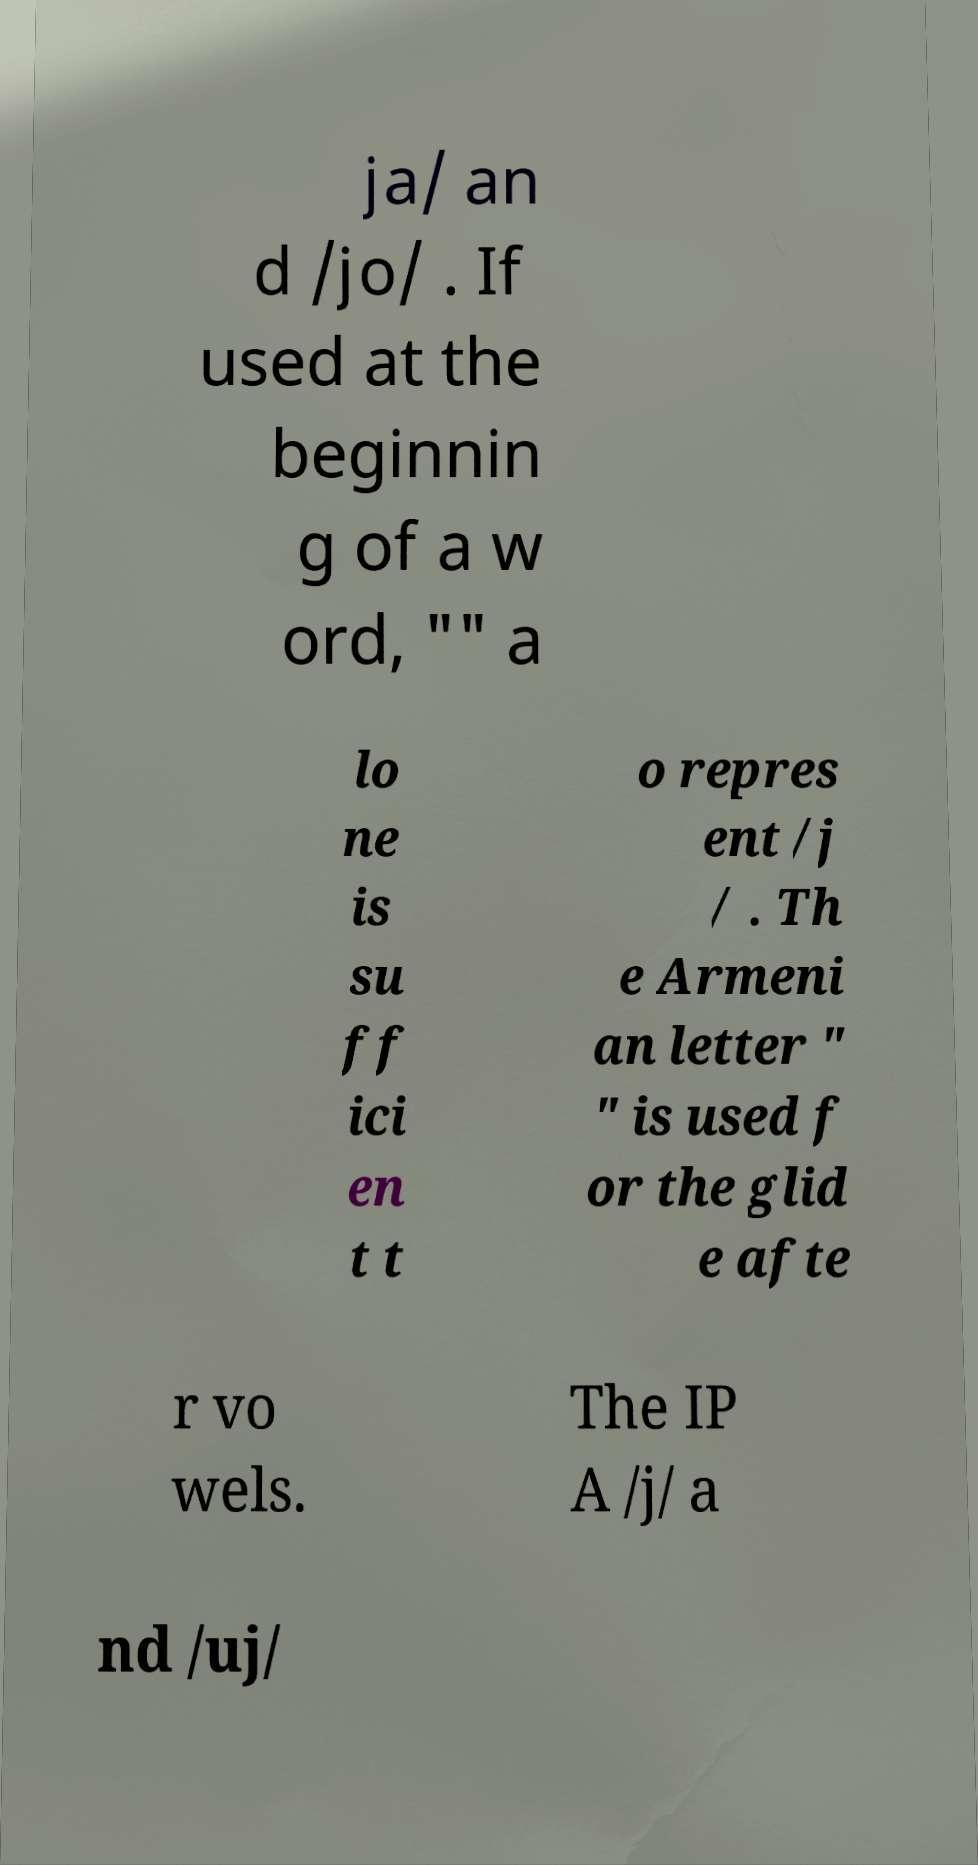There's text embedded in this image that I need extracted. Can you transcribe it verbatim? ja/ an d /jo/ . If used at the beginnin g of a w ord, "" a lo ne is su ff ici en t t o repres ent /j / . Th e Armeni an letter " " is used f or the glid e afte r vo wels. The IP A /j/ a nd /uj/ 